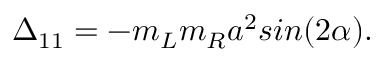Convert formula to latex. <formula><loc_0><loc_0><loc_500><loc_500>\Delta _ { 1 1 } = - m _ { L } m _ { R } a ^ { 2 } \sin ( 2 \alpha ) .</formula> 